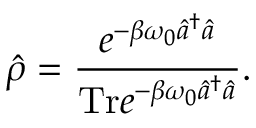<formula> <loc_0><loc_0><loc_500><loc_500>\hat { \rho } = \frac { e ^ { - \beta \omega _ { 0 } \hat { a } ^ { \dagger } \hat { a } } } { T r e ^ { - \beta \omega _ { 0 } \hat { a } ^ { \dagger } \hat { a } } } .</formula> 